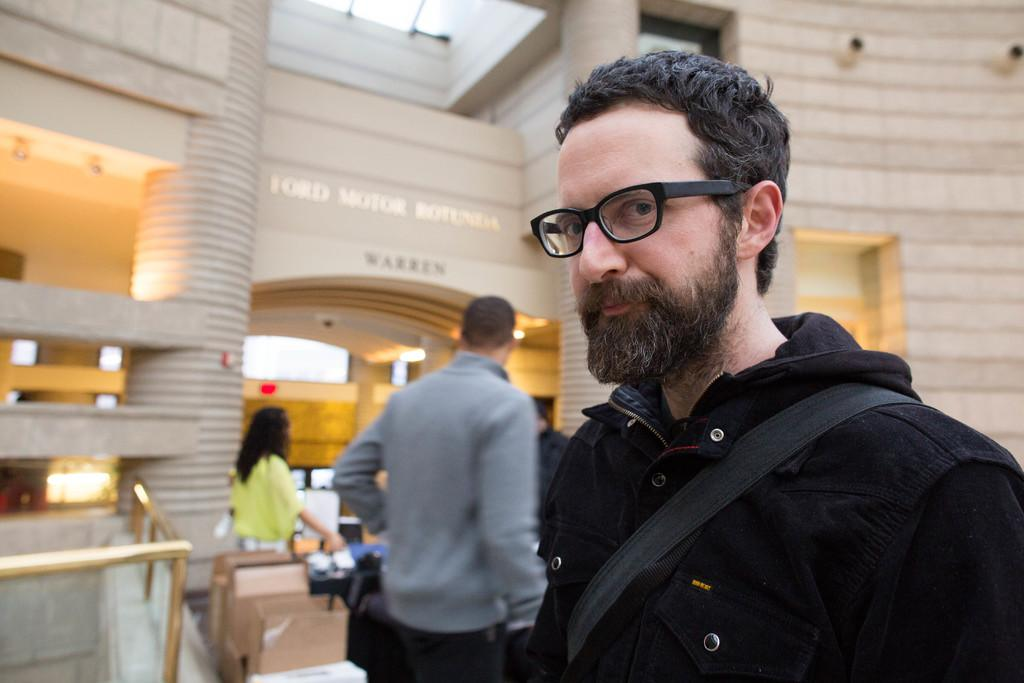What is the person in the foreground of the picture wearing? The person in the foreground of the picture is wearing a black jacket. How would you describe the background of the image? The background of the image is blurred. What can be seen in the background of the image besides the blurred scene? There are people, boxes, a railing, and a building in the background of the image. Is there any poison visible in the image? There is no poison present in the image. Are there any giants visible in the image? There are no giants present in the image. 